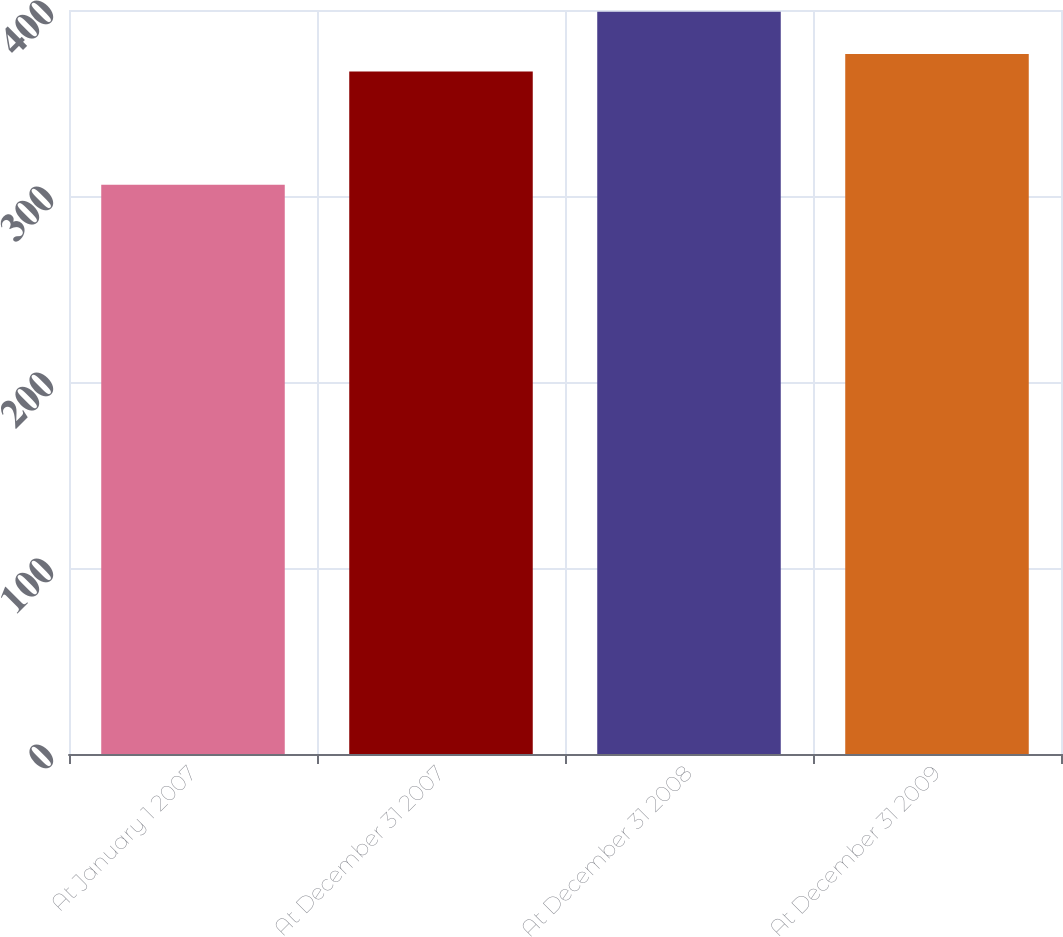<chart> <loc_0><loc_0><loc_500><loc_500><bar_chart><fcel>At January 1 2007<fcel>At December 31 2007<fcel>At December 31 2008<fcel>At December 31 2009<nl><fcel>306<fcel>367<fcel>399<fcel>376.3<nl></chart> 